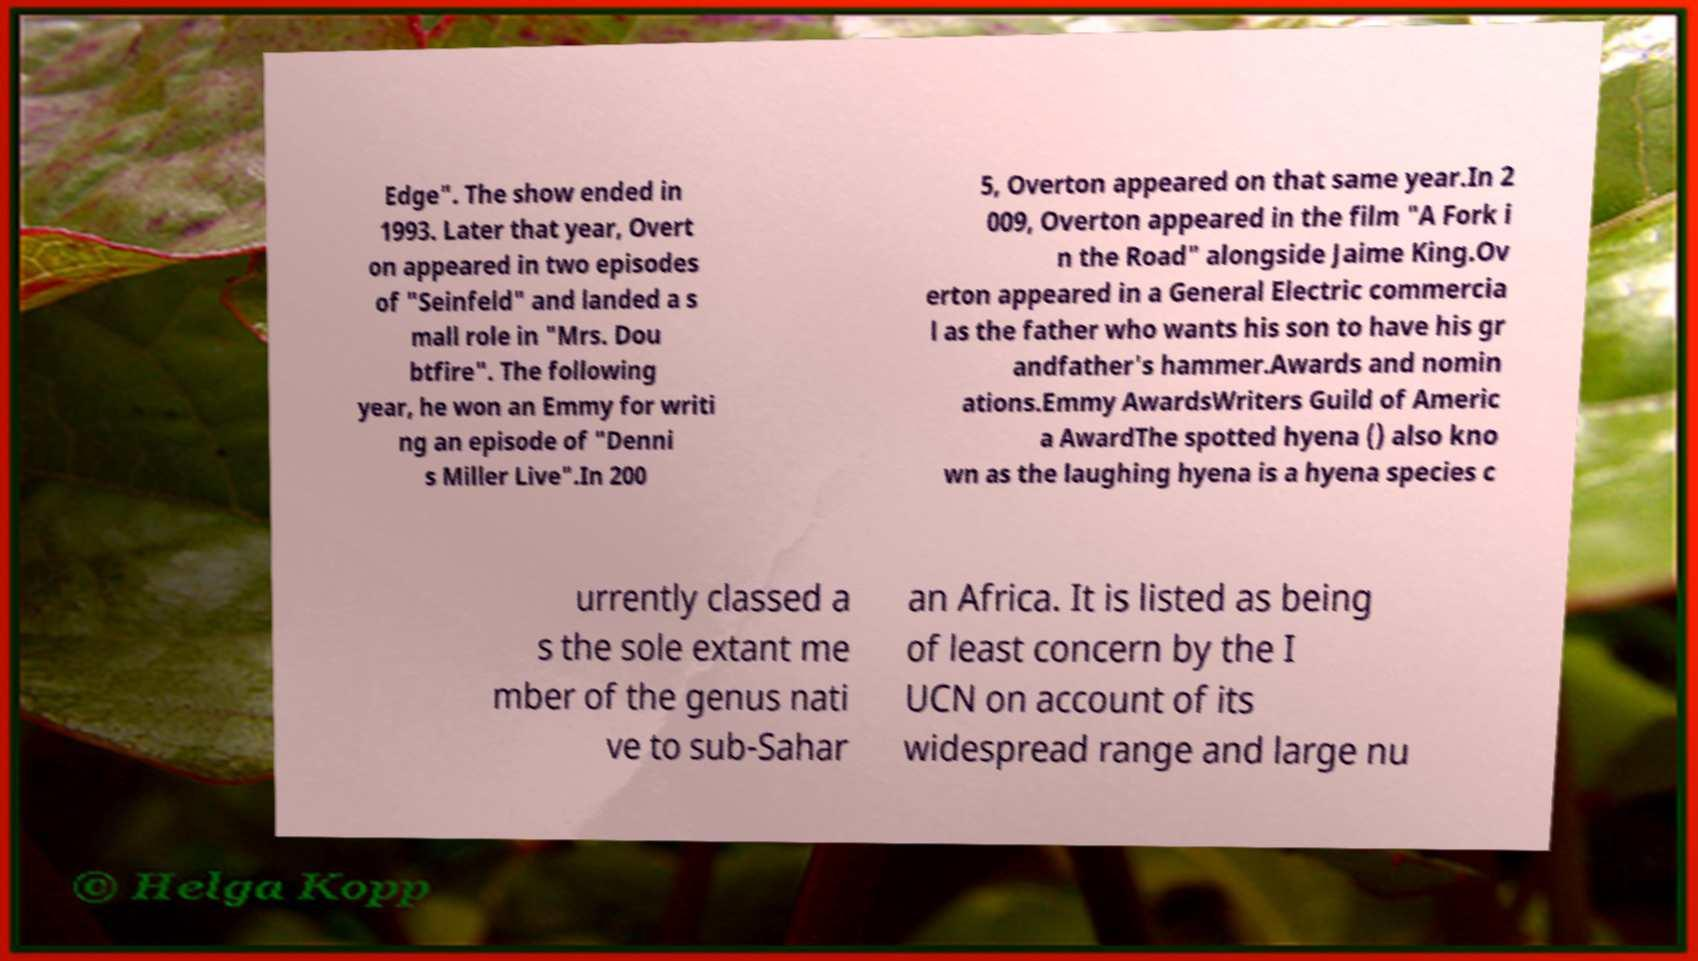Can you read and provide the text displayed in the image?This photo seems to have some interesting text. Can you extract and type it out for me? Edge". The show ended in 1993. Later that year, Overt on appeared in two episodes of "Seinfeld" and landed a s mall role in "Mrs. Dou btfire". The following year, he won an Emmy for writi ng an episode of "Denni s Miller Live".In 200 5, Overton appeared on that same year.In 2 009, Overton appeared in the film "A Fork i n the Road" alongside Jaime King.Ov erton appeared in a General Electric commercia l as the father who wants his son to have his gr andfather's hammer.Awards and nomin ations.Emmy AwardsWriters Guild of Americ a AwardThe spotted hyena () also kno wn as the laughing hyena is a hyena species c urrently classed a s the sole extant me mber of the genus nati ve to sub-Sahar an Africa. It is listed as being of least concern by the I UCN on account of its widespread range and large nu 